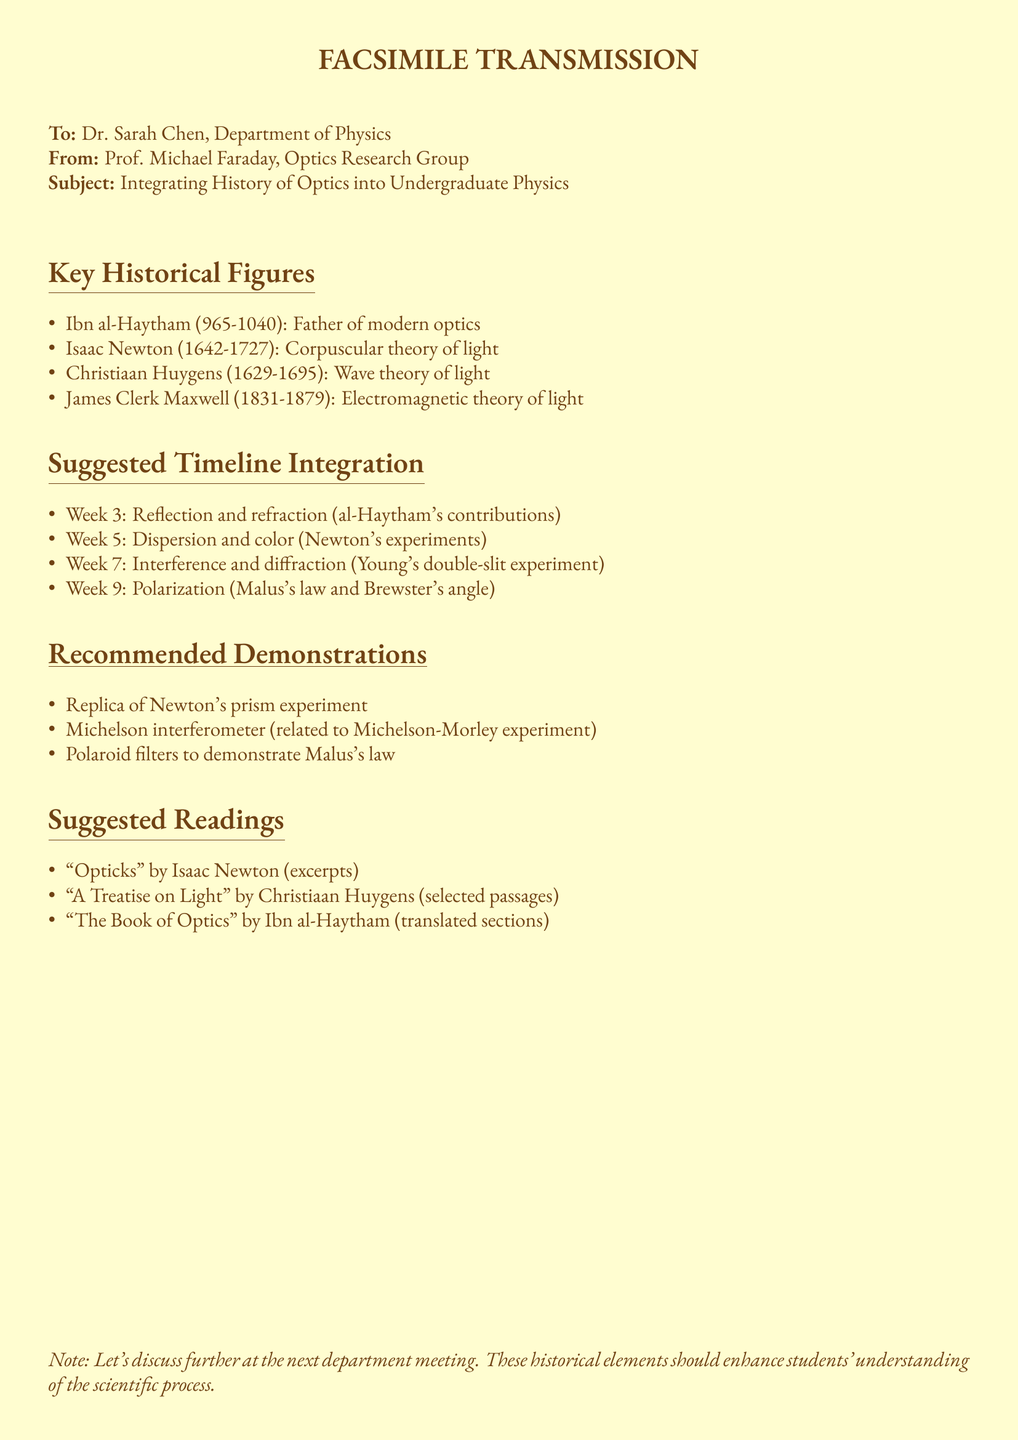What is the name of the first key historical figure mentioned? The first key historical figure mentioned is Ibn al-Haytham, recognized as the Father of modern optics.
Answer: Ibn al-Haytham In which week are Newton's experiments on dispersion and color discussed? The document mentions Newton's experiments in week 5.
Answer: Week 5 What historical figure's contributions are related to reflection and refraction? Reflection and refraction are associated with the contributions of Ibn al-Haytham.
Answer: Ibn al-Haytham Which experiment is associated with week 7? Week 7 focuses on interference and diffraction, specifically referencing Young's double-slit experiment.
Answer: Young's double-slit experiment What type of filter is suggested to demonstrate Malus's law? The recommended filter to demonstrate Malus's law is Polaroid filters.
Answer: Polaroid filters What book by Isaac Newton is suggested for reading? The reading suggested from Isaac Newton is "Opticks".
Answer: "Opticks" What is the overall intent of integrating history into the physics course? The intent is to enhance students' understanding of the scientific process through historical context.
Answer: Enhance understanding Who sent the fax? The sender of the fax is Prof. Michael Faraday.
Answer: Prof. Michael Faraday What device is related to the Michelson-Morley experiment? The device recommended for demonstrations is the Michelson interferometer.
Answer: Michelson interferometer 